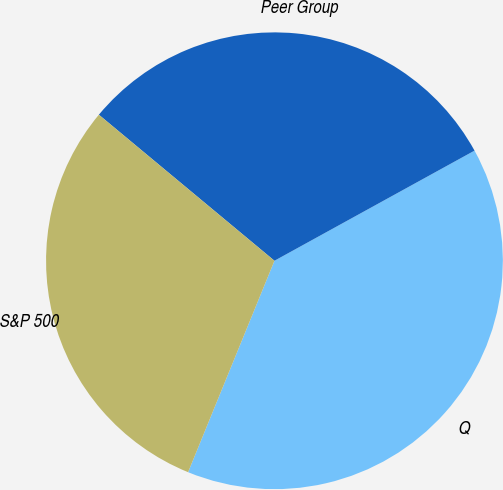Convert chart. <chart><loc_0><loc_0><loc_500><loc_500><pie_chart><fcel>Q<fcel>Peer Group<fcel>S&P 500<nl><fcel>39.18%<fcel>30.95%<fcel>29.87%<nl></chart> 